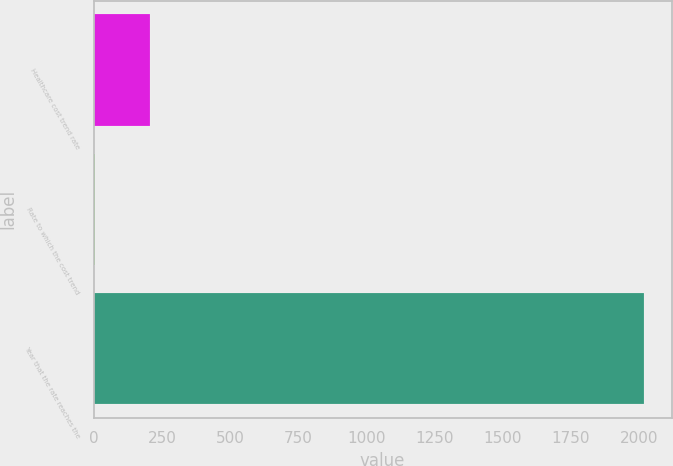<chart> <loc_0><loc_0><loc_500><loc_500><bar_chart><fcel>Healthcare cost trend rate<fcel>Rate to which the cost trend<fcel>Year that the rate reaches the<nl><fcel>205.86<fcel>4.51<fcel>2018<nl></chart> 